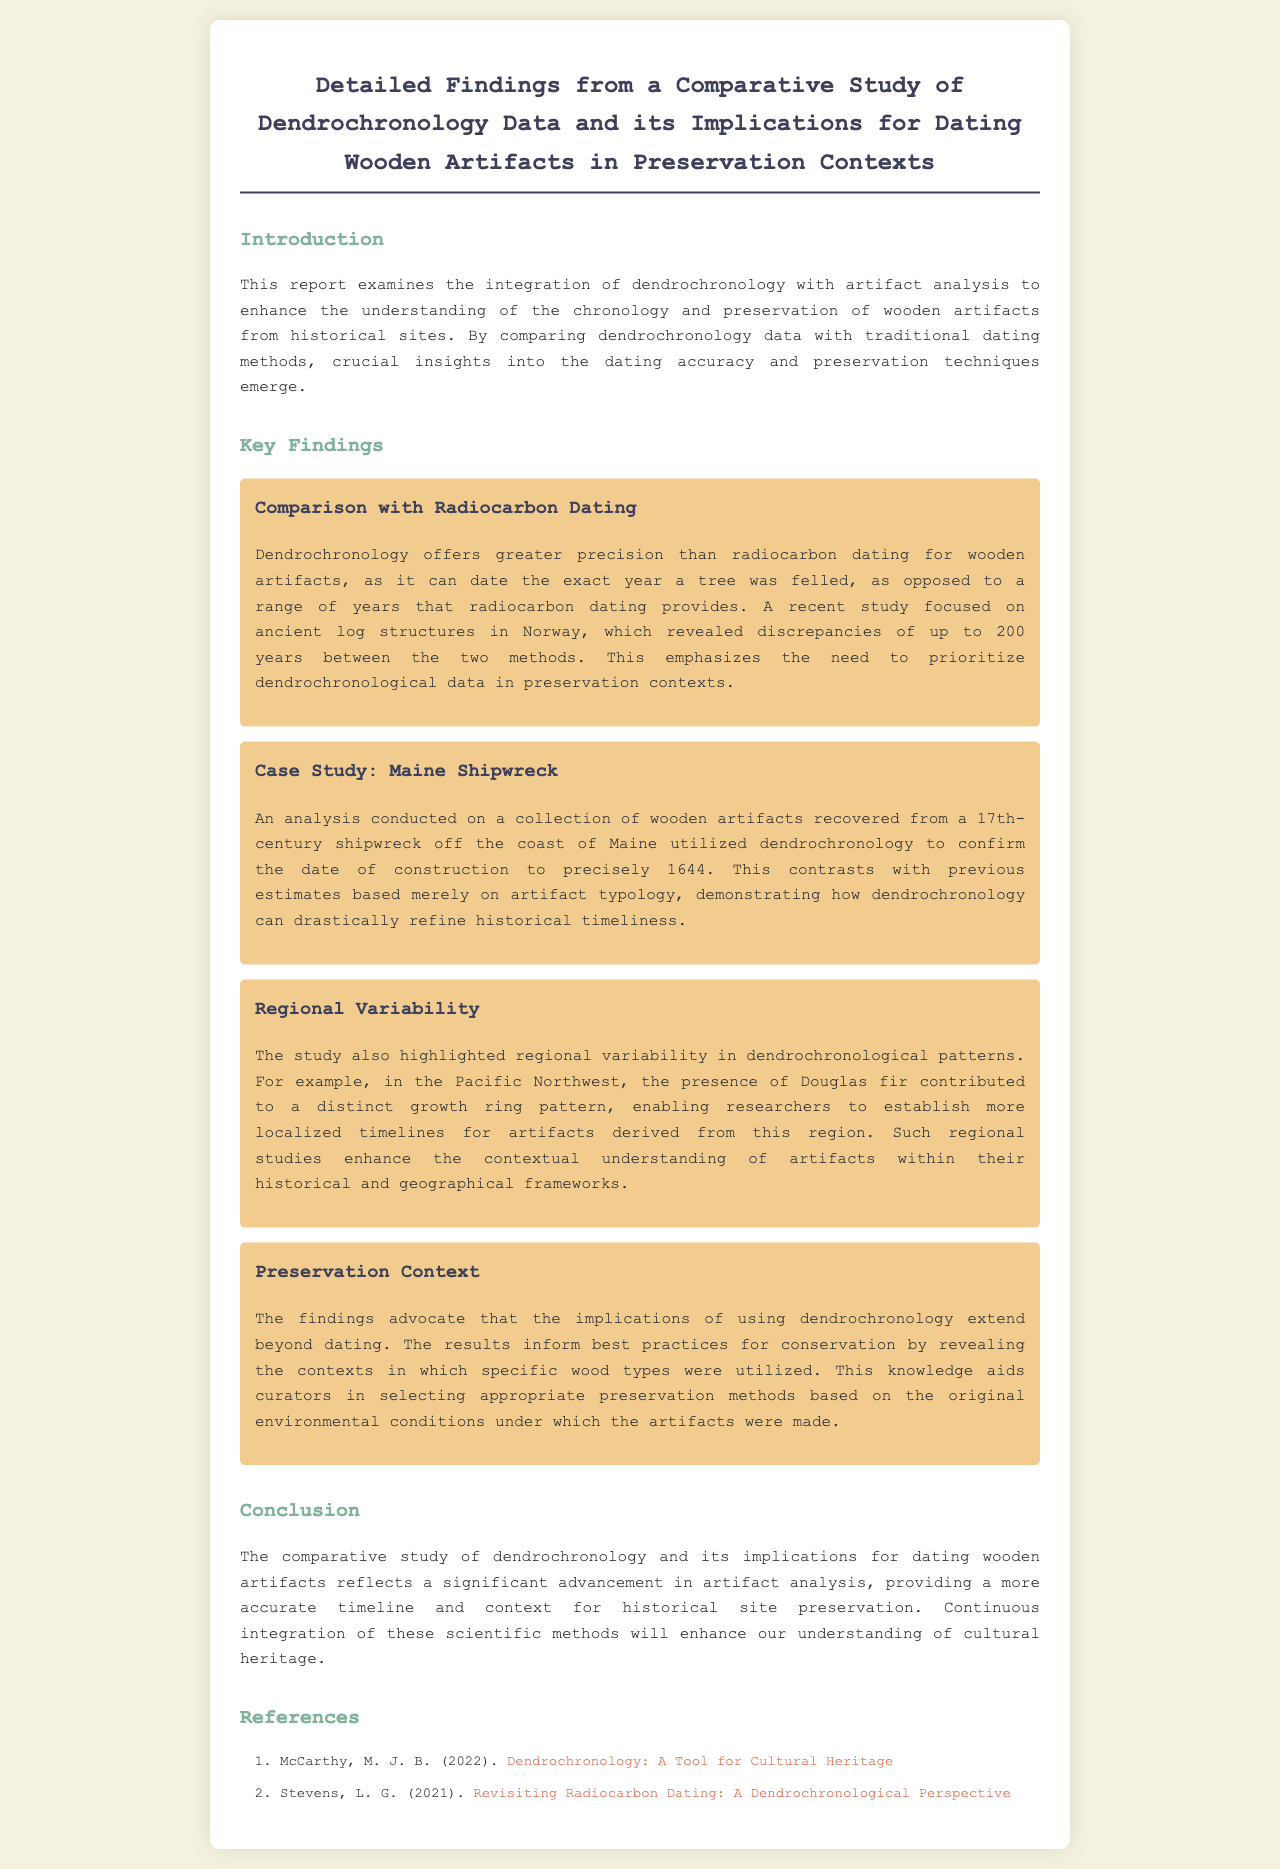What is the title of the report? The title of the report is clearly stated at the beginning, summarizing the main focus of the study.
Answer: Detailed Findings from a Comparative Study of Dendrochronology Data and its Implications for Dating Wooden Artifacts in Preservation Contexts What year was the construction of the shipwreck confirmed? The report specifies that dendrochronology confirmed the construction date of the shipwreck to 1644, emphasizing the effectiveness of this method in dating artifacts.
Answer: 1644 Which method provides greater precision for dating wooden artifacts? The findings compare the effectiveness of dendrochronology with radiocarbon dating, favoring one over the other.
Answer: Dendrochronology What geographical area shows distinct growth ring patterns? The report highlights specific regions where unique growth patterns influence the dating of artifacts, naming a particular area as an example.
Answer: Pacific Northwest What is emphasized as a crucial need in preservation contexts? The findings indicate a discrepancy between methods which leads to a recommendation for prioritizing one approach in certain situations.
Answer: Prioritize dendrochronological data What type of knowledge does dendrochronology provide for conservators? The implications of dendrochronology extend beyond mere dating; it informs specific best practices.
Answer: Contexts in which specific wood types were utilized What is the main conclusion of the study? The conclusion synthesizes the results of the comparative study, reiterating the importance of integrating modern methods into traditional practices.
Answer: Advancement in artifact analysis What year was the Maine shipwreck analyzed? The study focuses on a historical artifact and provides a dedicated analysis for a specific time period linking the findings comprehensively.
Answer: 17th century 